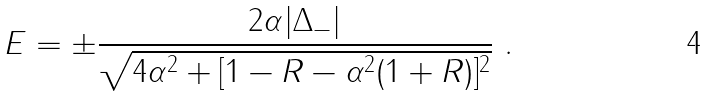Convert formula to latex. <formula><loc_0><loc_0><loc_500><loc_500>E = \pm \frac { 2 \alpha | \Delta _ { - } | } { \sqrt { 4 \alpha ^ { 2 } + [ 1 - R - \alpha ^ { 2 } ( 1 + R ) ] ^ { 2 } } } \ .</formula> 